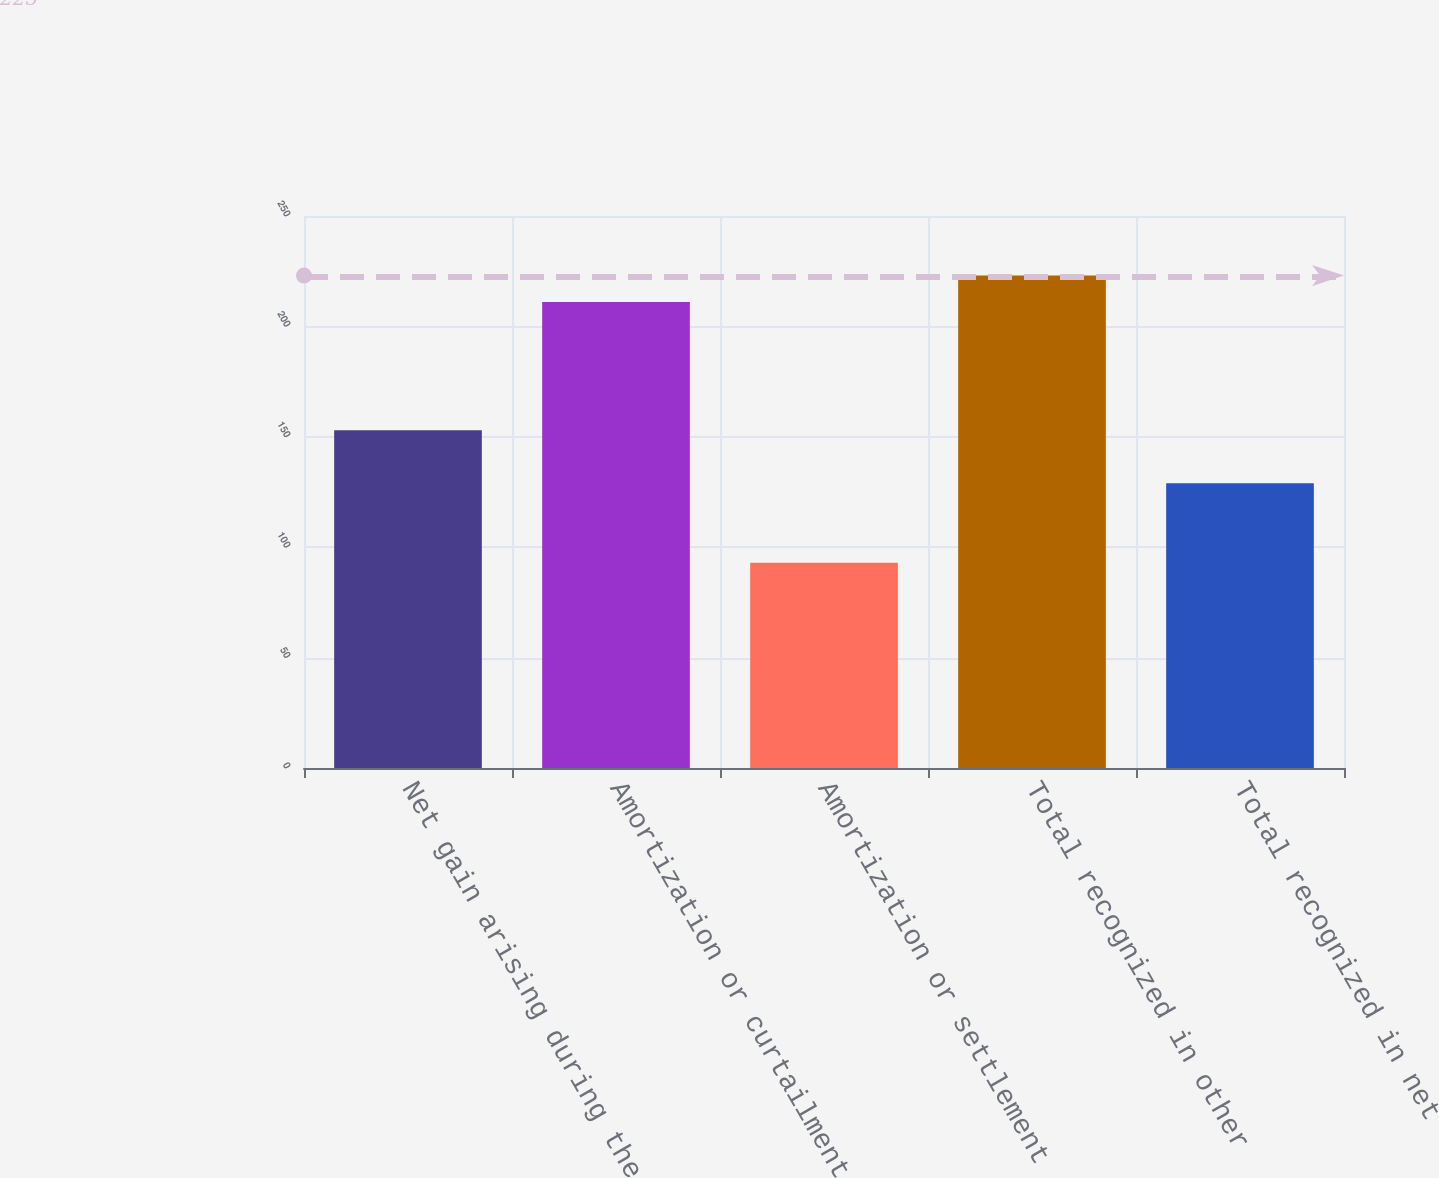Convert chart. <chart><loc_0><loc_0><loc_500><loc_500><bar_chart><fcel>Net gain arising during the<fcel>Amortization or curtailment<fcel>Amortization or settlement<fcel>Total recognized in other<fcel>Total recognized in net<nl><fcel>153<fcel>211<fcel>93<fcel>223<fcel>129<nl></chart> 